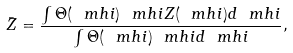Convert formula to latex. <formula><loc_0><loc_0><loc_500><loc_500>\bar { Z } = \frac { \int \Theta ( \ m h i ) \ m h i Z ( \ m h i ) d \ m h i } { \int \Theta ( \ m h i ) \ m h i d \ m h i } ,</formula> 